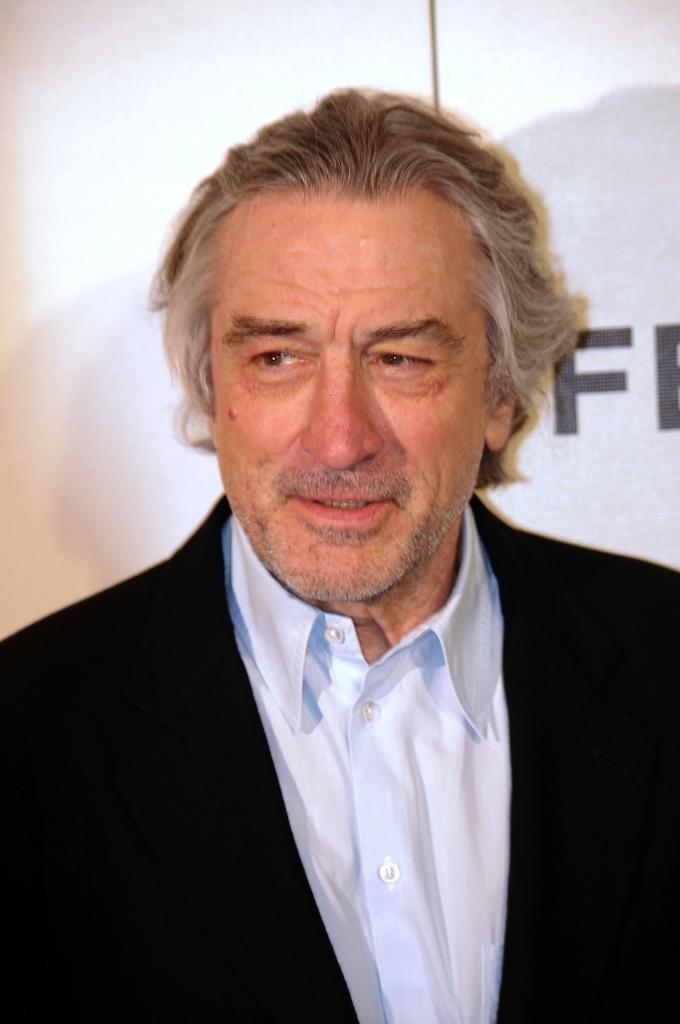Who is present in the image? There is a man in the image. What is the man wearing? The man is wearing a black suit. What can be seen in the background of the image? There is text on a white wall in the background of the image. What type of brass instrument is the man playing in the image? There is no brass instrument present in the image; the man is simply wearing a black suit. 